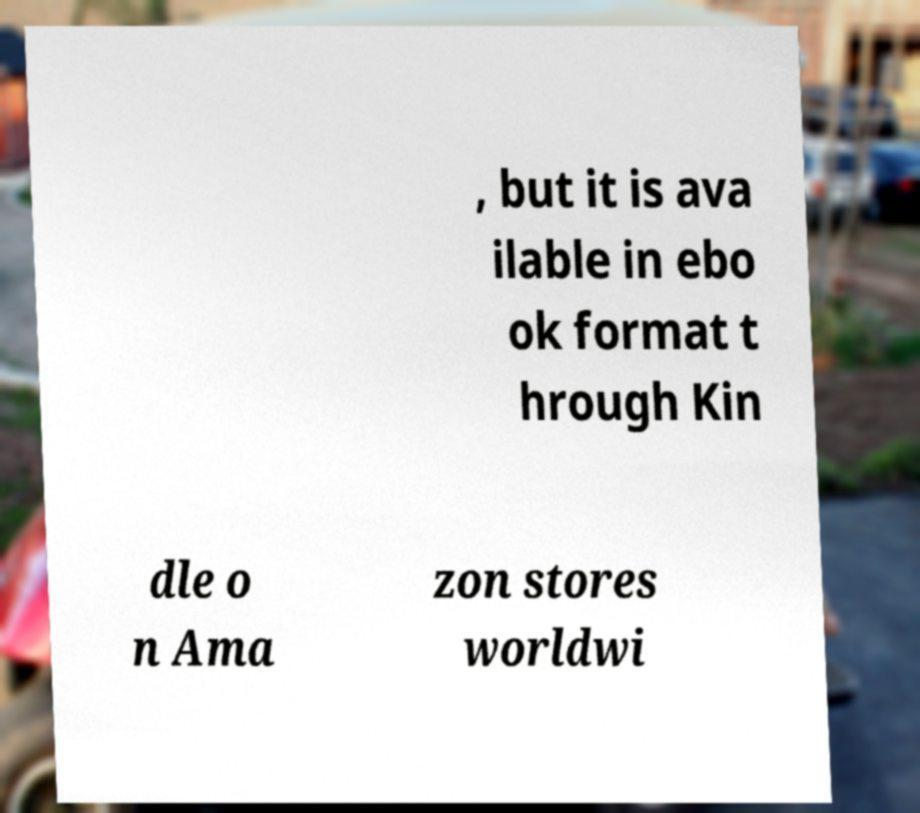Can you accurately transcribe the text from the provided image for me? , but it is ava ilable in ebo ok format t hrough Kin dle o n Ama zon stores worldwi 